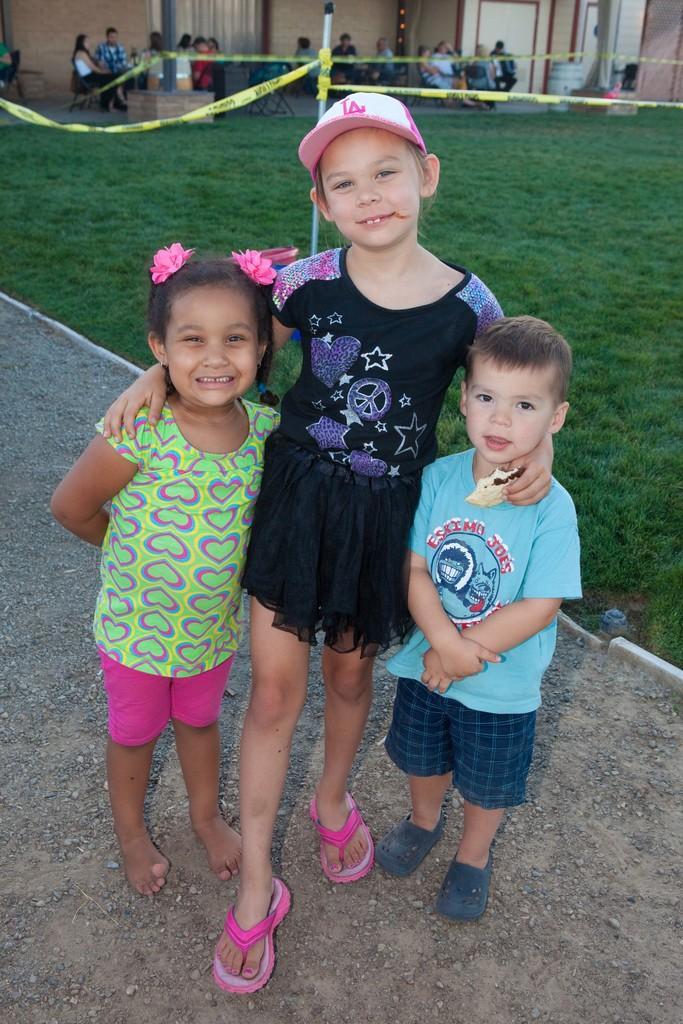How would you summarize this image in a sentence or two? In this picture we can see three kids standing and smiling. We can see a kid wearing a cap is holding an object in the hand. Some grass is visible on the ground. We can see a few people sitting on the chair. There are a few objects and a building is visible in the background. 